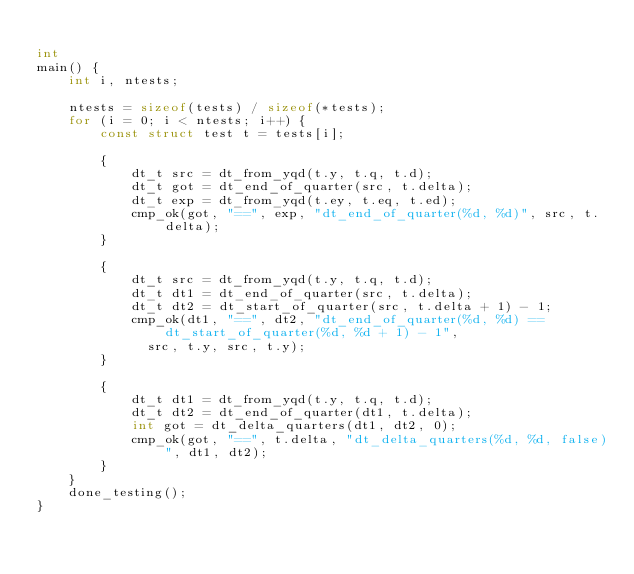<code> <loc_0><loc_0><loc_500><loc_500><_C_>
int 
main() {
    int i, ntests;

    ntests = sizeof(tests) / sizeof(*tests);
    for (i = 0; i < ntests; i++) {
        const struct test t = tests[i];

        {
            dt_t src = dt_from_yqd(t.y, t.q, t.d);
            dt_t got = dt_end_of_quarter(src, t.delta);
            dt_t exp = dt_from_yqd(t.ey, t.eq, t.ed);
            cmp_ok(got, "==", exp, "dt_end_of_quarter(%d, %d)", src, t.delta);
        }

        {
            dt_t src = dt_from_yqd(t.y, t.q, t.d);
            dt_t dt1 = dt_end_of_quarter(src, t.delta);
            dt_t dt2 = dt_start_of_quarter(src, t.delta + 1) - 1;
            cmp_ok(dt1, "==", dt2, "dt_end_of_quarter(%d, %d) == dt_start_of_quarter(%d, %d + 1) - 1",
              src, t.y, src, t.y);
        }

        {
            dt_t dt1 = dt_from_yqd(t.y, t.q, t.d);
            dt_t dt2 = dt_end_of_quarter(dt1, t.delta);
            int got = dt_delta_quarters(dt1, dt2, 0);
            cmp_ok(got, "==", t.delta, "dt_delta_quarters(%d, %d, false)", dt1, dt2);
        }
    }
    done_testing();
}

</code> 